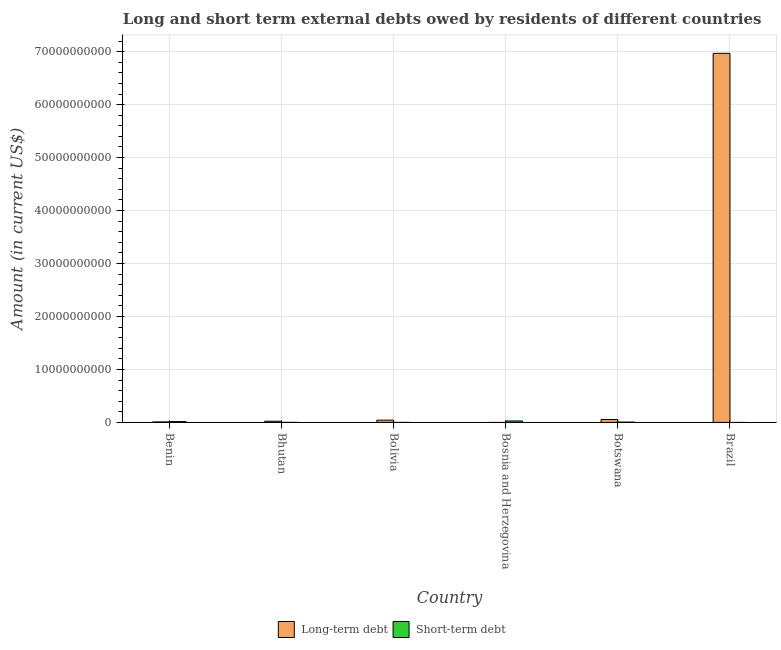Are the number of bars per tick equal to the number of legend labels?
Ensure brevity in your answer.  No. How many bars are there on the 2nd tick from the right?
Your response must be concise. 2. What is the label of the 1st group of bars from the left?
Ensure brevity in your answer.  Benin. In how many cases, is the number of bars for a given country not equal to the number of legend labels?
Provide a succinct answer. 3. What is the long-term debts owed by residents in Botswana?
Ensure brevity in your answer.  5.44e+08. Across all countries, what is the maximum short-term debts owed by residents?
Your answer should be compact. 2.70e+08. Across all countries, what is the minimum short-term debts owed by residents?
Offer a terse response. 0. In which country was the short-term debts owed by residents maximum?
Your answer should be compact. Bosnia and Herzegovina. What is the total short-term debts owed by residents in the graph?
Give a very brief answer. 4.80e+08. What is the difference between the long-term debts owed by residents in Benin and that in Botswana?
Provide a succinct answer. -4.57e+08. What is the difference between the short-term debts owed by residents in Bolivia and the long-term debts owed by residents in Brazil?
Your answer should be compact. -6.97e+1. What is the average short-term debts owed by residents per country?
Provide a succinct answer. 7.99e+07. What is the difference between the long-term debts owed by residents and short-term debts owed by residents in Bhutan?
Your answer should be compact. 2.23e+08. What is the ratio of the long-term debts owed by residents in Bhutan to that in Brazil?
Your response must be concise. 0. What is the difference between the highest and the second highest short-term debts owed by residents?
Provide a short and direct response. 1.16e+08. What is the difference between the highest and the lowest long-term debts owed by residents?
Ensure brevity in your answer.  6.97e+1. In how many countries, is the long-term debts owed by residents greater than the average long-term debts owed by residents taken over all countries?
Your response must be concise. 1. How many bars are there?
Your answer should be compact. 9. How many countries are there in the graph?
Your answer should be very brief. 6. What is the difference between two consecutive major ticks on the Y-axis?
Your answer should be very brief. 1.00e+1. How many legend labels are there?
Your response must be concise. 2. How are the legend labels stacked?
Keep it short and to the point. Horizontal. What is the title of the graph?
Keep it short and to the point. Long and short term external debts owed by residents of different countries. What is the label or title of the X-axis?
Ensure brevity in your answer.  Country. What is the label or title of the Y-axis?
Provide a succinct answer. Amount (in current US$). What is the Amount (in current US$) in Long-term debt in Benin?
Your answer should be very brief. 8.69e+07. What is the Amount (in current US$) in Short-term debt in Benin?
Your answer should be compact. 1.54e+08. What is the Amount (in current US$) in Long-term debt in Bhutan?
Ensure brevity in your answer.  2.25e+08. What is the Amount (in current US$) in Long-term debt in Bolivia?
Your answer should be very brief. 4.25e+08. What is the Amount (in current US$) in Short-term debt in Bosnia and Herzegovina?
Provide a short and direct response. 2.70e+08. What is the Amount (in current US$) of Long-term debt in Botswana?
Offer a terse response. 5.44e+08. What is the Amount (in current US$) in Short-term debt in Botswana?
Provide a succinct answer. 5.40e+07. What is the Amount (in current US$) of Long-term debt in Brazil?
Keep it short and to the point. 6.97e+1. Across all countries, what is the maximum Amount (in current US$) in Long-term debt?
Ensure brevity in your answer.  6.97e+1. Across all countries, what is the maximum Amount (in current US$) of Short-term debt?
Provide a succinct answer. 2.70e+08. Across all countries, what is the minimum Amount (in current US$) in Short-term debt?
Offer a terse response. 0. What is the total Amount (in current US$) of Long-term debt in the graph?
Offer a very short reply. 7.10e+1. What is the total Amount (in current US$) in Short-term debt in the graph?
Offer a very short reply. 4.80e+08. What is the difference between the Amount (in current US$) in Long-term debt in Benin and that in Bhutan?
Offer a very short reply. -1.38e+08. What is the difference between the Amount (in current US$) in Short-term debt in Benin and that in Bhutan?
Make the answer very short. 1.52e+08. What is the difference between the Amount (in current US$) in Long-term debt in Benin and that in Bolivia?
Your answer should be very brief. -3.38e+08. What is the difference between the Amount (in current US$) of Short-term debt in Benin and that in Bosnia and Herzegovina?
Give a very brief answer. -1.16e+08. What is the difference between the Amount (in current US$) of Long-term debt in Benin and that in Botswana?
Give a very brief answer. -4.57e+08. What is the difference between the Amount (in current US$) in Short-term debt in Benin and that in Botswana?
Make the answer very short. 9.97e+07. What is the difference between the Amount (in current US$) of Long-term debt in Benin and that in Brazil?
Give a very brief answer. -6.96e+1. What is the difference between the Amount (in current US$) of Long-term debt in Bhutan and that in Bolivia?
Offer a terse response. -2.00e+08. What is the difference between the Amount (in current US$) of Short-term debt in Bhutan and that in Bosnia and Herzegovina?
Your response must be concise. -2.68e+08. What is the difference between the Amount (in current US$) of Long-term debt in Bhutan and that in Botswana?
Make the answer very short. -3.19e+08. What is the difference between the Amount (in current US$) in Short-term debt in Bhutan and that in Botswana?
Offer a very short reply. -5.20e+07. What is the difference between the Amount (in current US$) of Long-term debt in Bhutan and that in Brazil?
Your answer should be compact. -6.95e+1. What is the difference between the Amount (in current US$) in Long-term debt in Bolivia and that in Botswana?
Your answer should be very brief. -1.19e+08. What is the difference between the Amount (in current US$) of Long-term debt in Bolivia and that in Brazil?
Provide a succinct answer. -6.93e+1. What is the difference between the Amount (in current US$) of Short-term debt in Bosnia and Herzegovina and that in Botswana?
Your answer should be compact. 2.16e+08. What is the difference between the Amount (in current US$) in Long-term debt in Botswana and that in Brazil?
Keep it short and to the point. -6.91e+1. What is the difference between the Amount (in current US$) of Long-term debt in Benin and the Amount (in current US$) of Short-term debt in Bhutan?
Offer a terse response. 8.49e+07. What is the difference between the Amount (in current US$) of Long-term debt in Benin and the Amount (in current US$) of Short-term debt in Bosnia and Herzegovina?
Provide a short and direct response. -1.83e+08. What is the difference between the Amount (in current US$) of Long-term debt in Benin and the Amount (in current US$) of Short-term debt in Botswana?
Ensure brevity in your answer.  3.29e+07. What is the difference between the Amount (in current US$) in Long-term debt in Bhutan and the Amount (in current US$) in Short-term debt in Bosnia and Herzegovina?
Provide a short and direct response. -4.52e+07. What is the difference between the Amount (in current US$) in Long-term debt in Bhutan and the Amount (in current US$) in Short-term debt in Botswana?
Offer a very short reply. 1.71e+08. What is the difference between the Amount (in current US$) of Long-term debt in Bolivia and the Amount (in current US$) of Short-term debt in Bosnia and Herzegovina?
Your response must be concise. 1.55e+08. What is the difference between the Amount (in current US$) in Long-term debt in Bolivia and the Amount (in current US$) in Short-term debt in Botswana?
Offer a terse response. 3.71e+08. What is the average Amount (in current US$) in Long-term debt per country?
Ensure brevity in your answer.  1.18e+1. What is the average Amount (in current US$) in Short-term debt per country?
Your answer should be very brief. 7.99e+07. What is the difference between the Amount (in current US$) of Long-term debt and Amount (in current US$) of Short-term debt in Benin?
Keep it short and to the point. -6.68e+07. What is the difference between the Amount (in current US$) in Long-term debt and Amount (in current US$) in Short-term debt in Bhutan?
Offer a terse response. 2.23e+08. What is the difference between the Amount (in current US$) in Long-term debt and Amount (in current US$) in Short-term debt in Botswana?
Make the answer very short. 4.90e+08. What is the ratio of the Amount (in current US$) of Long-term debt in Benin to that in Bhutan?
Your answer should be very brief. 0.39. What is the ratio of the Amount (in current US$) of Short-term debt in Benin to that in Bhutan?
Offer a terse response. 76.83. What is the ratio of the Amount (in current US$) of Long-term debt in Benin to that in Bolivia?
Provide a succinct answer. 0.2. What is the ratio of the Amount (in current US$) in Short-term debt in Benin to that in Bosnia and Herzegovina?
Provide a succinct answer. 0.57. What is the ratio of the Amount (in current US$) in Long-term debt in Benin to that in Botswana?
Keep it short and to the point. 0.16. What is the ratio of the Amount (in current US$) in Short-term debt in Benin to that in Botswana?
Give a very brief answer. 2.85. What is the ratio of the Amount (in current US$) in Long-term debt in Benin to that in Brazil?
Keep it short and to the point. 0. What is the ratio of the Amount (in current US$) in Long-term debt in Bhutan to that in Bolivia?
Provide a short and direct response. 0.53. What is the ratio of the Amount (in current US$) in Short-term debt in Bhutan to that in Bosnia and Herzegovina?
Offer a very short reply. 0.01. What is the ratio of the Amount (in current US$) in Long-term debt in Bhutan to that in Botswana?
Offer a terse response. 0.41. What is the ratio of the Amount (in current US$) of Short-term debt in Bhutan to that in Botswana?
Give a very brief answer. 0.04. What is the ratio of the Amount (in current US$) in Long-term debt in Bhutan to that in Brazil?
Provide a succinct answer. 0. What is the ratio of the Amount (in current US$) of Long-term debt in Bolivia to that in Botswana?
Make the answer very short. 0.78. What is the ratio of the Amount (in current US$) in Long-term debt in Bolivia to that in Brazil?
Offer a very short reply. 0.01. What is the ratio of the Amount (in current US$) of Long-term debt in Botswana to that in Brazil?
Ensure brevity in your answer.  0.01. What is the difference between the highest and the second highest Amount (in current US$) of Long-term debt?
Give a very brief answer. 6.91e+1. What is the difference between the highest and the second highest Amount (in current US$) in Short-term debt?
Ensure brevity in your answer.  1.16e+08. What is the difference between the highest and the lowest Amount (in current US$) in Long-term debt?
Provide a short and direct response. 6.97e+1. What is the difference between the highest and the lowest Amount (in current US$) in Short-term debt?
Ensure brevity in your answer.  2.70e+08. 